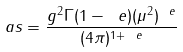Convert formula to latex. <formula><loc_0><loc_0><loc_500><loc_500>\ a s = \frac { g ^ { 2 } \Gamma ( 1 - \ e ) ( \mu ^ { 2 } ) ^ { \ e } } { ( 4 \pi ) ^ { 1 + \ e } }</formula> 